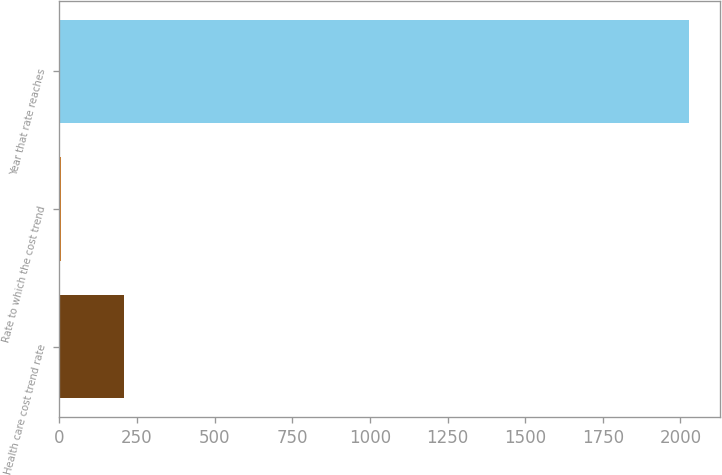<chart> <loc_0><loc_0><loc_500><loc_500><bar_chart><fcel>Health care cost trend rate<fcel>Rate to which the cost trend<fcel>Year that rate reaches<nl><fcel>206.75<fcel>4.5<fcel>2027<nl></chart> 